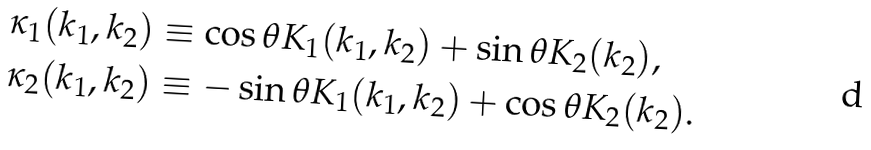Convert formula to latex. <formula><loc_0><loc_0><loc_500><loc_500>\kappa _ { 1 } ( k _ { 1 } , k _ { 2 } ) & \equiv \cos \theta K _ { 1 } ( k _ { 1 } , k _ { 2 } ) + \sin \theta K _ { 2 } ( k _ { 2 } ) , \\ \kappa _ { 2 } ( k _ { 1 } , k _ { 2 } ) & \equiv - \sin \theta K _ { 1 } ( k _ { 1 } , k _ { 2 } ) + \cos \theta K _ { 2 } ( k _ { 2 } ) .</formula> 